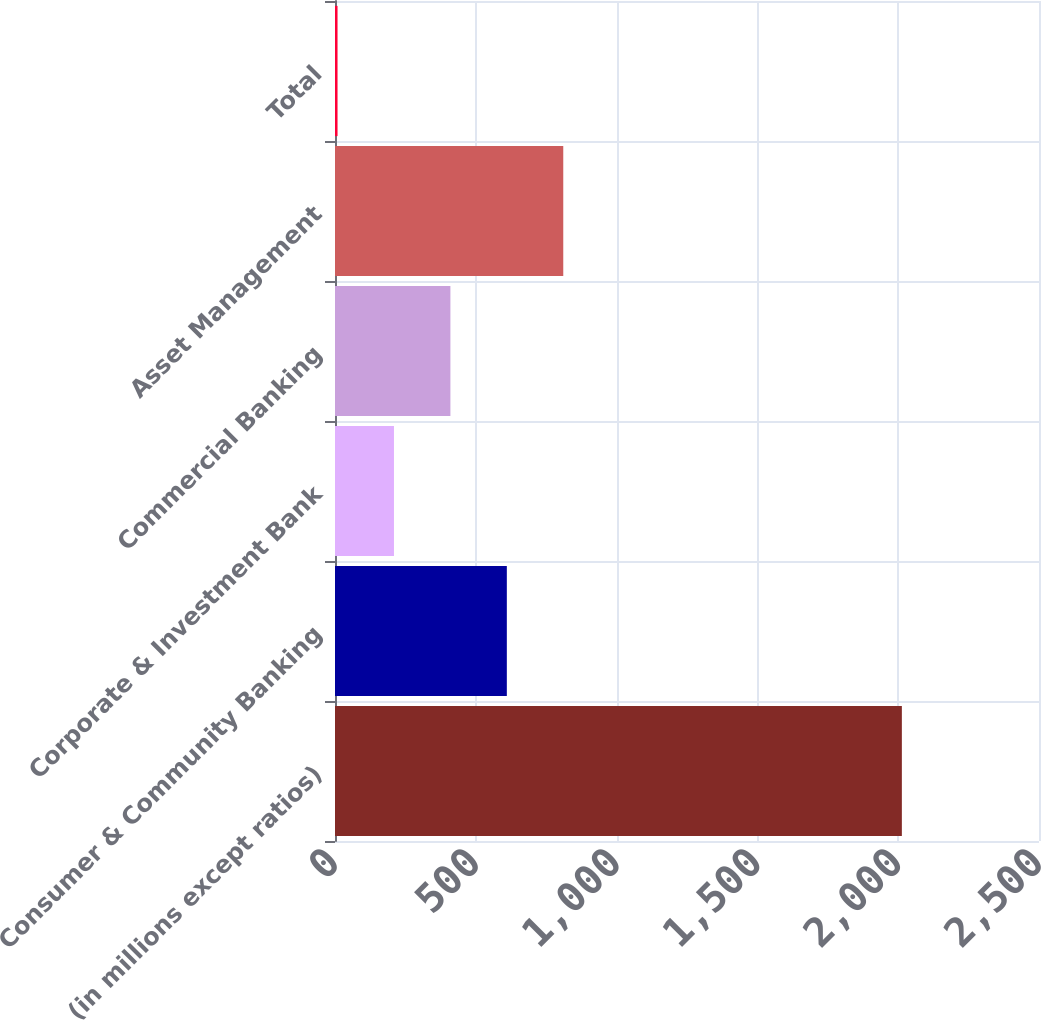Convert chart. <chart><loc_0><loc_0><loc_500><loc_500><bar_chart><fcel>(in millions except ratios)<fcel>Consumer & Community Banking<fcel>Corporate & Investment Bank<fcel>Commercial Banking<fcel>Asset Management<fcel>Total<nl><fcel>2013<fcel>610.2<fcel>209.4<fcel>409.8<fcel>810.6<fcel>9<nl></chart> 